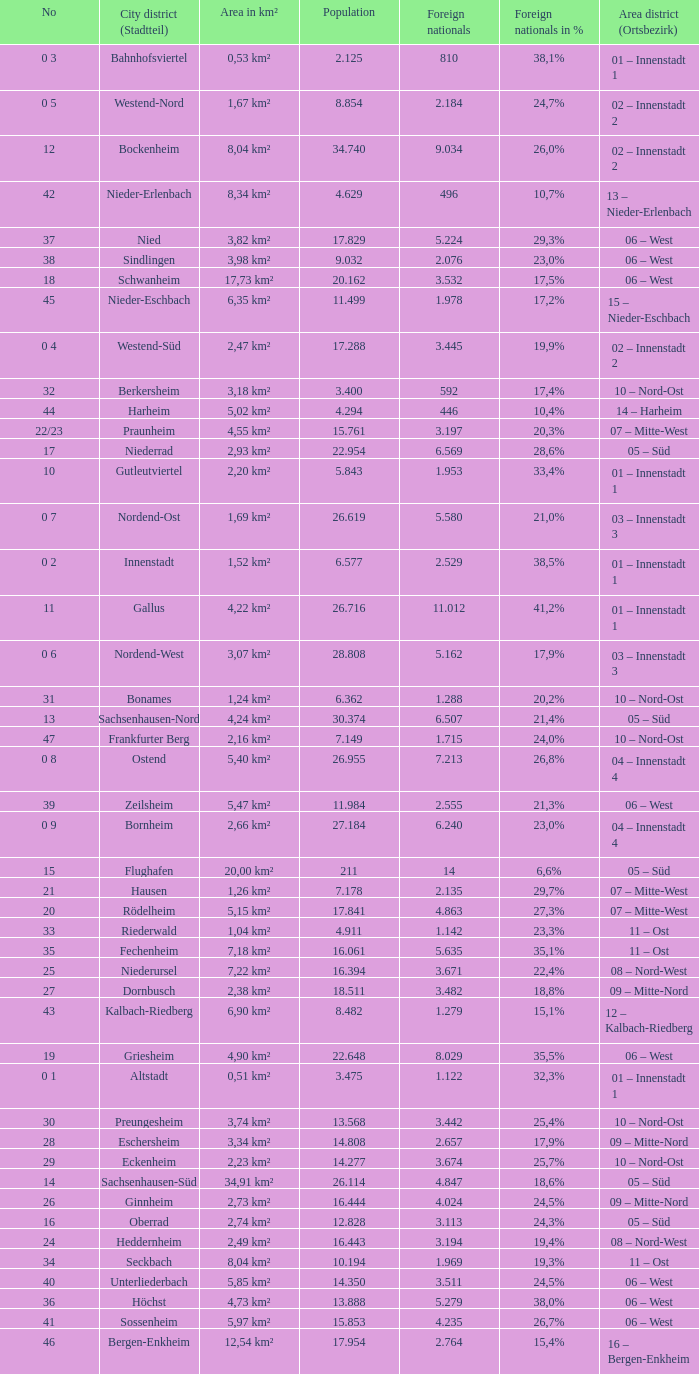What is the number of the city district of stadtteil where foreigners are 5.162? 1.0. 